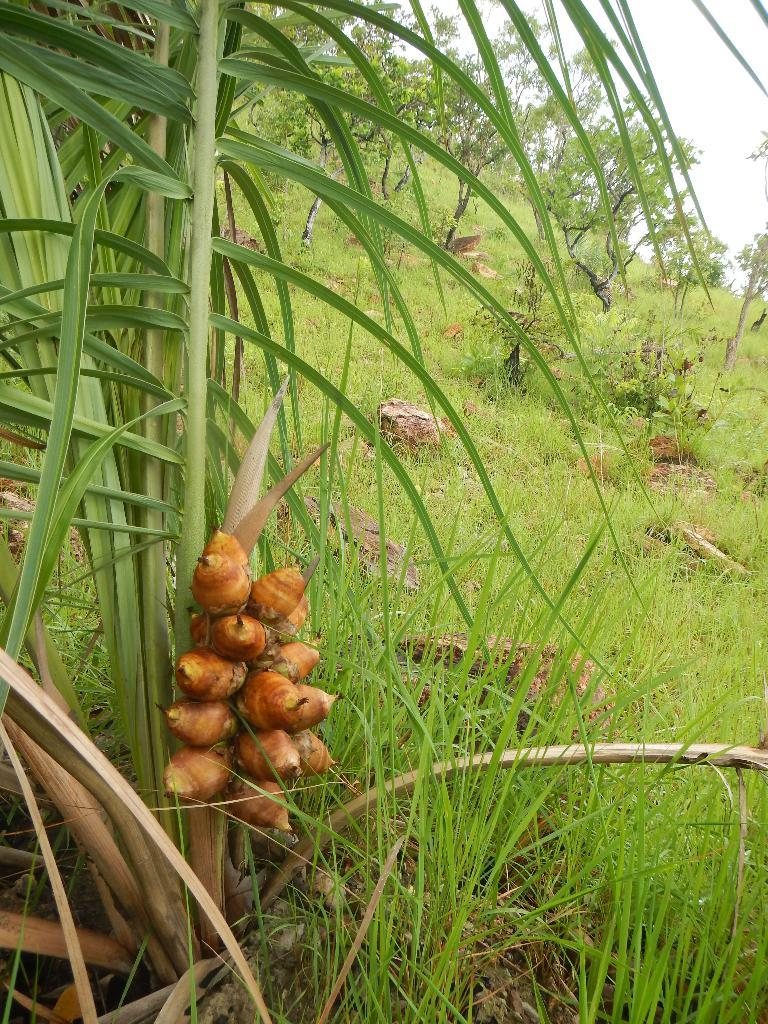What type of food can be seen on the left side of the image? There are fruits on the left side of the image. What is covering the ground in the image? There is grass on the ground in the image. What can be seen in the background of the image? There are plants and the sky visible in the background of the image. What type of clover is being used as a legal document in the image? There is no clover or legal document present in the image. Can you identify the stem of the plant in the image? The provided facts do not mention a specific plant or stem, so it cannot be identified from the image. 